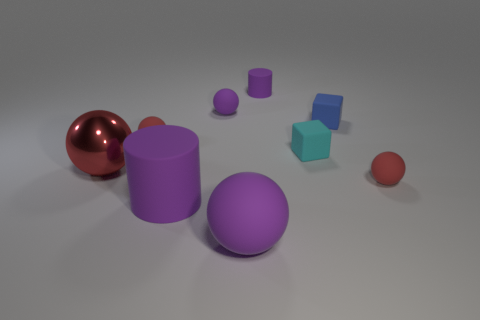How many cylinders are either blue rubber objects or purple objects?
Your answer should be compact. 2. What is the size of the purple cylinder that is in front of the small matte sphere in front of the big shiny sphere that is in front of the blue matte thing?
Provide a succinct answer. Large. What is the shape of the blue matte thing that is the same size as the cyan block?
Keep it short and to the point. Cube. What is the shape of the small blue matte thing?
Provide a succinct answer. Cube. Is the material of the small cube that is in front of the tiny blue block the same as the blue block?
Give a very brief answer. Yes. There is a metal ball behind the rubber cylinder in front of the tiny purple rubber cylinder; how big is it?
Ensure brevity in your answer.  Large. There is a rubber ball that is both on the left side of the cyan thing and right of the small purple ball; what is its color?
Your answer should be very brief. Purple. There is a purple sphere that is the same size as the red metallic thing; what is it made of?
Make the answer very short. Rubber. What number of other things are the same material as the small purple ball?
Your response must be concise. 7. Do the rubber cylinder that is behind the shiny object and the cylinder in front of the shiny ball have the same color?
Keep it short and to the point. Yes. 